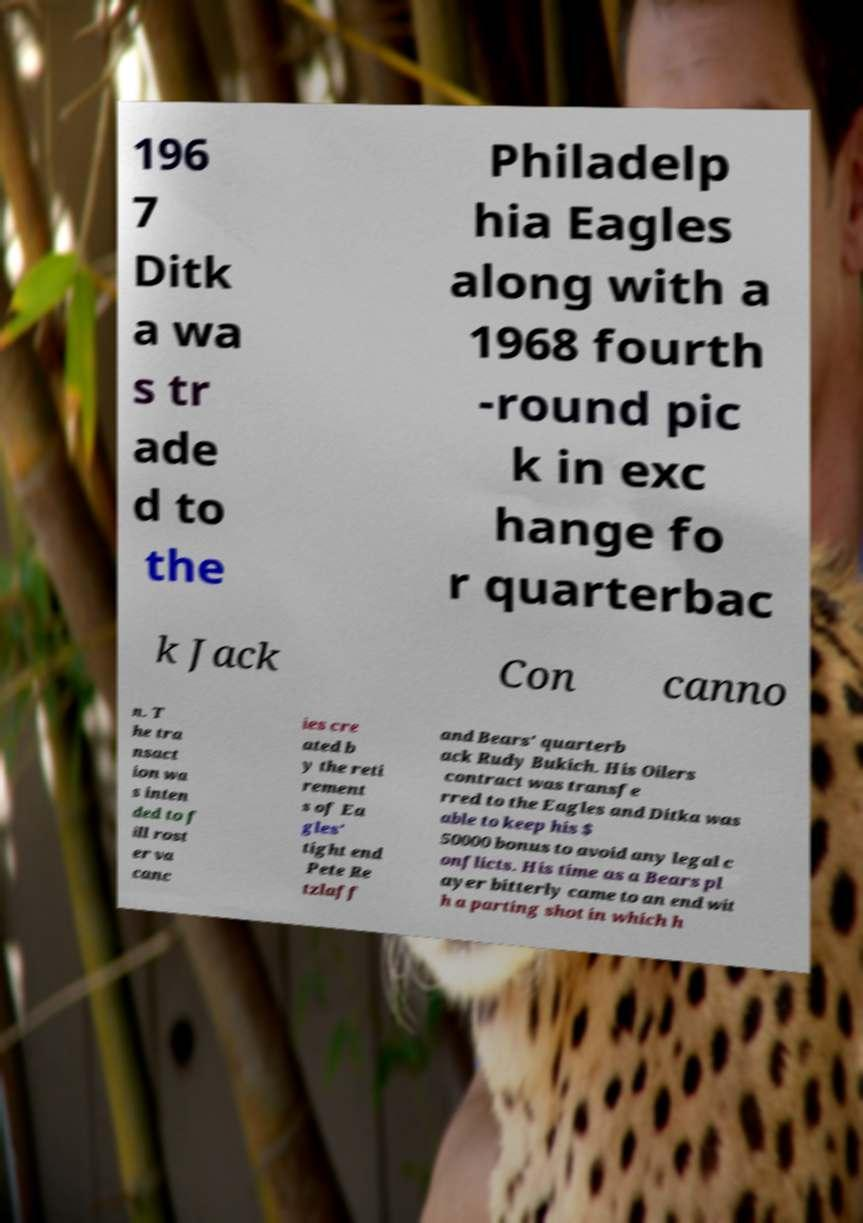I need the written content from this picture converted into text. Can you do that? 196 7 Ditk a wa s tr ade d to the Philadelp hia Eagles along with a 1968 fourth -round pic k in exc hange fo r quarterbac k Jack Con canno n. T he tra nsact ion wa s inten ded to f ill rost er va canc ies cre ated b y the reti rement s of Ea gles' tight end Pete Re tzlaff and Bears' quarterb ack Rudy Bukich. His Oilers contract was transfe rred to the Eagles and Ditka was able to keep his $ 50000 bonus to avoid any legal c onflicts. His time as a Bears pl ayer bitterly came to an end wit h a parting shot in which h 